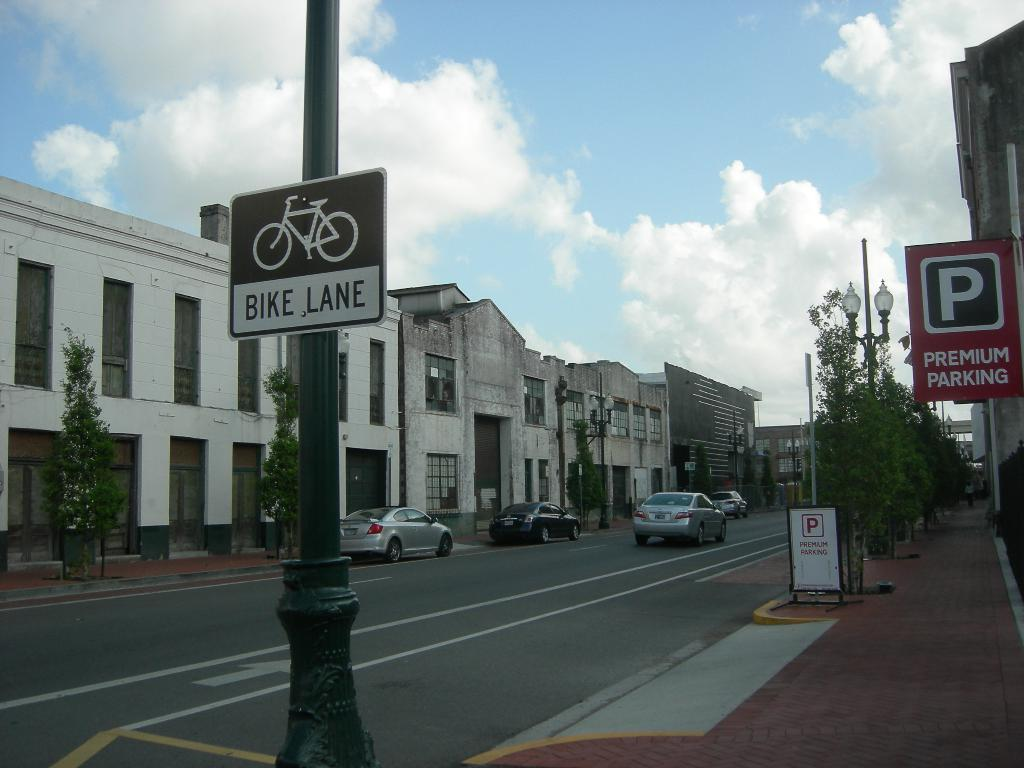What type of vehicles can be seen on the road in the image? There are cars on the road in the image. What natural elements are visible in the image? Trees are visible in the image. What structures are present in the image? Poles, boards, lights, and buildings are present in the image. What is visible in the background of the image? The sky is visible in the background of the image. What atmospheric conditions can be observed in the sky? Clouds are present in the sky. What type of oatmeal is being served in the image? There is no oatmeal present in the image. Can you hear the sounds of the cars in the image? The image is a visual representation, so there are no sounds to hear. 